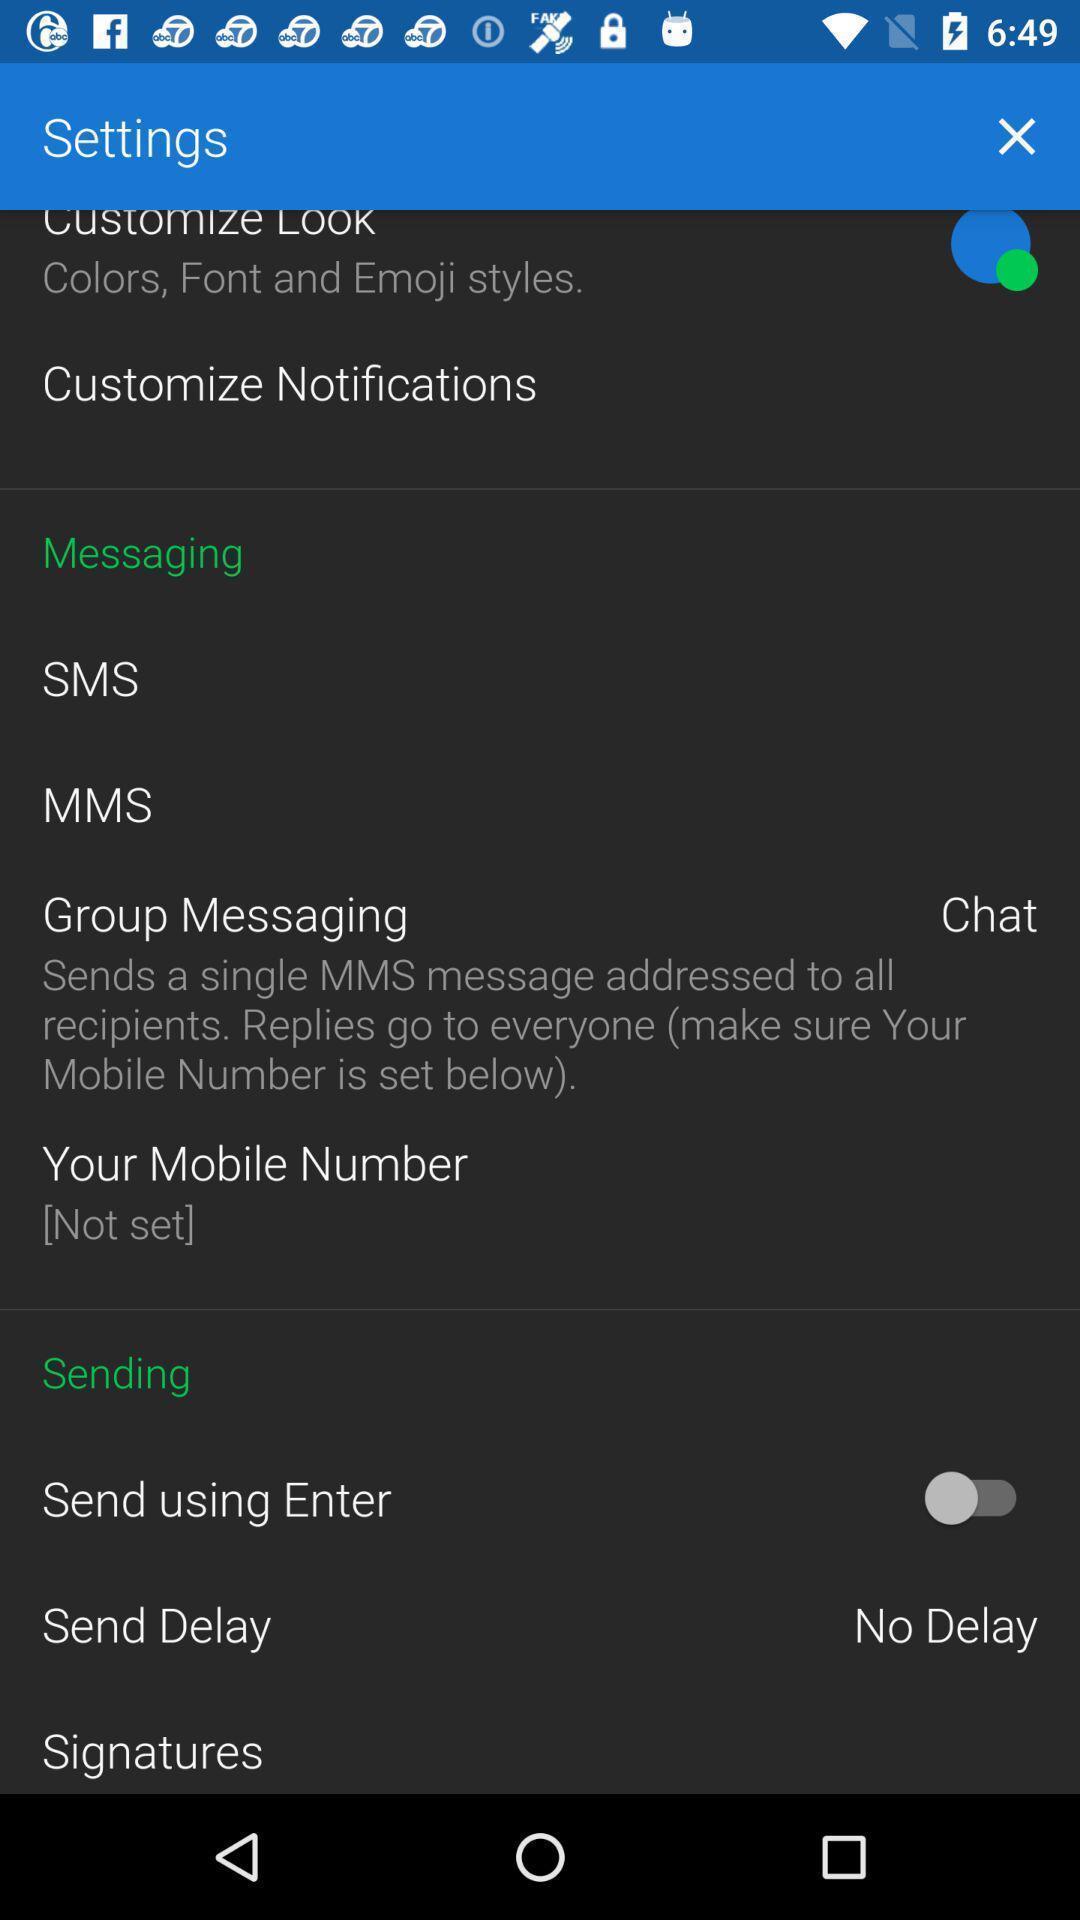Summarize the main components in this picture. Settings page. 